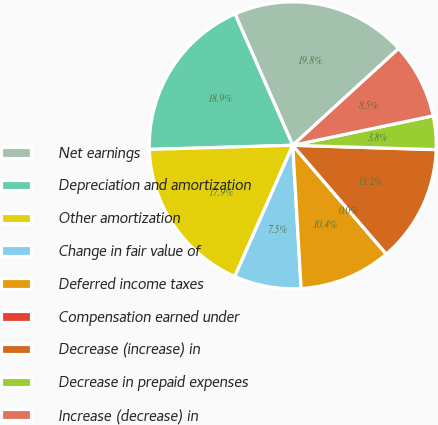Convert chart to OTSL. <chart><loc_0><loc_0><loc_500><loc_500><pie_chart><fcel>Net earnings<fcel>Depreciation and amortization<fcel>Other amortization<fcel>Change in fair value of<fcel>Deferred income taxes<fcel>Compensation earned under<fcel>Decrease (increase) in<fcel>Decrease in prepaid expenses<fcel>Increase (decrease) in<nl><fcel>19.81%<fcel>18.87%<fcel>17.92%<fcel>7.55%<fcel>10.38%<fcel>0.0%<fcel>13.21%<fcel>3.78%<fcel>8.49%<nl></chart> 